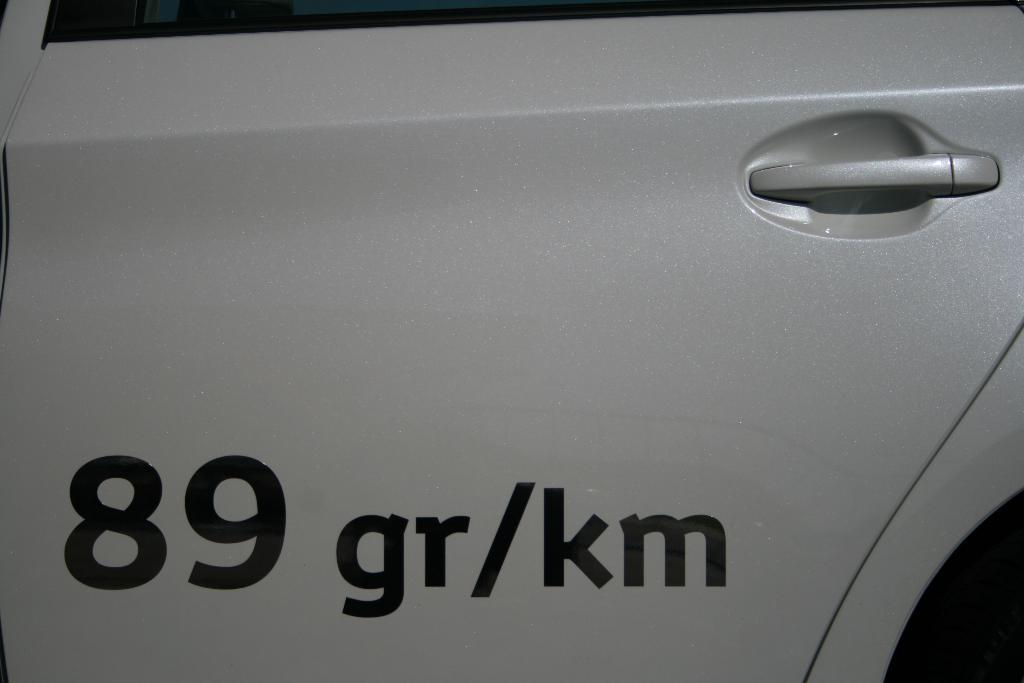What can be found on the vehicle's door in the image? There is text and numbers on the vehicle's door. Can you describe the text on the vehicle's door? Unfortunately, the specific text cannot be determined from the image alone. What do the numbers on the vehicle's door represent? The meaning of the numbers on the vehicle's door cannot be determined from the image alone. Is the stick used by the beginner visible in the image? There is no stick or beginner present in the image. What is the front of the vehicle in the image? The image does not show the entire vehicle, so it is impossible to determine the front from the available information. 